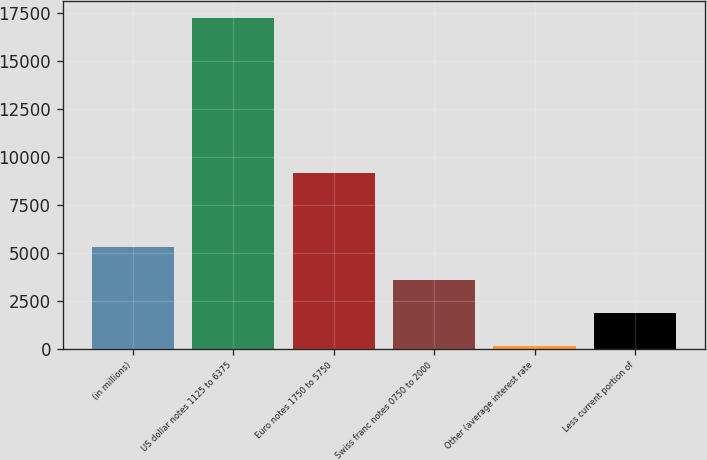Convert chart. <chart><loc_0><loc_0><loc_500><loc_500><bar_chart><fcel>(in millions)<fcel>US dollar notes 1125 to 6375<fcel>Euro notes 1750 to 5750<fcel>Swiss franc notes 0750 to 2000<fcel>Other (average interest rate<fcel>Less current portion of<nl><fcel>5285.6<fcel>17229<fcel>9161<fcel>3579.4<fcel>167<fcel>1873.2<nl></chart> 